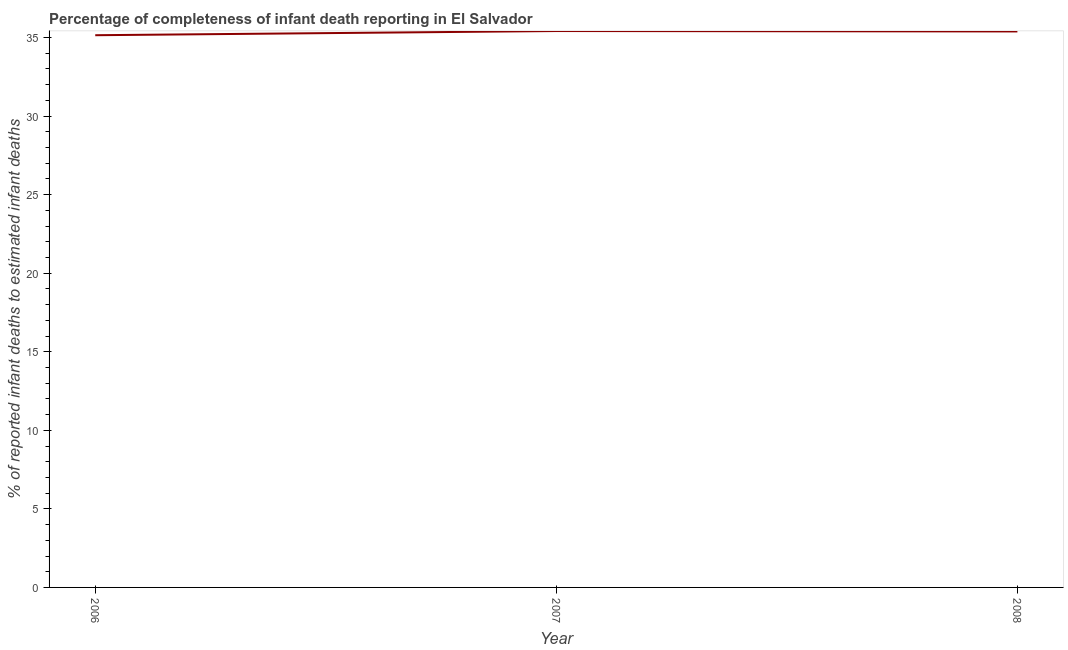What is the completeness of infant death reporting in 2007?
Your response must be concise. 35.42. Across all years, what is the maximum completeness of infant death reporting?
Give a very brief answer. 35.42. Across all years, what is the minimum completeness of infant death reporting?
Give a very brief answer. 35.15. In which year was the completeness of infant death reporting maximum?
Give a very brief answer. 2007. What is the sum of the completeness of infant death reporting?
Ensure brevity in your answer.  105.95. What is the difference between the completeness of infant death reporting in 2007 and 2008?
Your answer should be very brief. 0.03. What is the average completeness of infant death reporting per year?
Your answer should be very brief. 35.32. What is the median completeness of infant death reporting?
Your answer should be compact. 35.39. What is the ratio of the completeness of infant death reporting in 2007 to that in 2008?
Your response must be concise. 1. Is the completeness of infant death reporting in 2006 less than that in 2008?
Offer a terse response. Yes. What is the difference between the highest and the second highest completeness of infant death reporting?
Your answer should be very brief. 0.03. Is the sum of the completeness of infant death reporting in 2007 and 2008 greater than the maximum completeness of infant death reporting across all years?
Your answer should be compact. Yes. What is the difference between the highest and the lowest completeness of infant death reporting?
Your answer should be compact. 0.27. Does the completeness of infant death reporting monotonically increase over the years?
Provide a succinct answer. No. How many lines are there?
Give a very brief answer. 1. How many years are there in the graph?
Keep it short and to the point. 3. What is the difference between two consecutive major ticks on the Y-axis?
Ensure brevity in your answer.  5. Are the values on the major ticks of Y-axis written in scientific E-notation?
Your answer should be compact. No. Does the graph contain any zero values?
Make the answer very short. No. What is the title of the graph?
Provide a succinct answer. Percentage of completeness of infant death reporting in El Salvador. What is the label or title of the Y-axis?
Provide a short and direct response. % of reported infant deaths to estimated infant deaths. What is the % of reported infant deaths to estimated infant deaths in 2006?
Your answer should be very brief. 35.15. What is the % of reported infant deaths to estimated infant deaths of 2007?
Make the answer very short. 35.42. What is the % of reported infant deaths to estimated infant deaths of 2008?
Your response must be concise. 35.39. What is the difference between the % of reported infant deaths to estimated infant deaths in 2006 and 2007?
Give a very brief answer. -0.27. What is the difference between the % of reported infant deaths to estimated infant deaths in 2006 and 2008?
Give a very brief answer. -0.24. What is the difference between the % of reported infant deaths to estimated infant deaths in 2007 and 2008?
Make the answer very short. 0.03. What is the ratio of the % of reported infant deaths to estimated infant deaths in 2006 to that in 2008?
Ensure brevity in your answer.  0.99. What is the ratio of the % of reported infant deaths to estimated infant deaths in 2007 to that in 2008?
Keep it short and to the point. 1. 